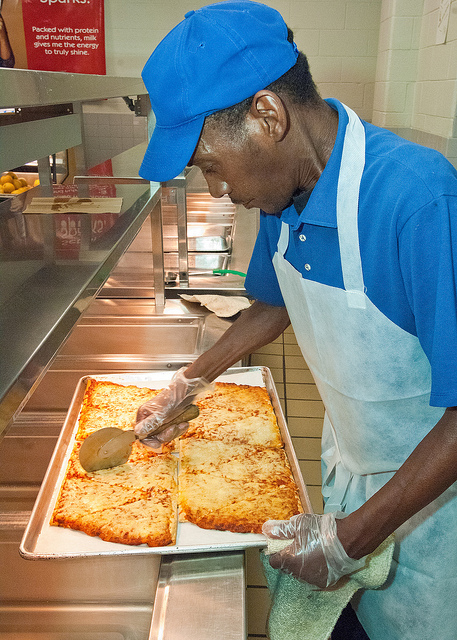<image>What kind of meat is in the pan? I'm not sure what kind of meat is in the pan. It could be beef, pepperoni, or no meat at all. What kind of meat is in the pan? It is uncertain what kind of meat is in the pan. It can be beef, pepperoni, or pizza. 